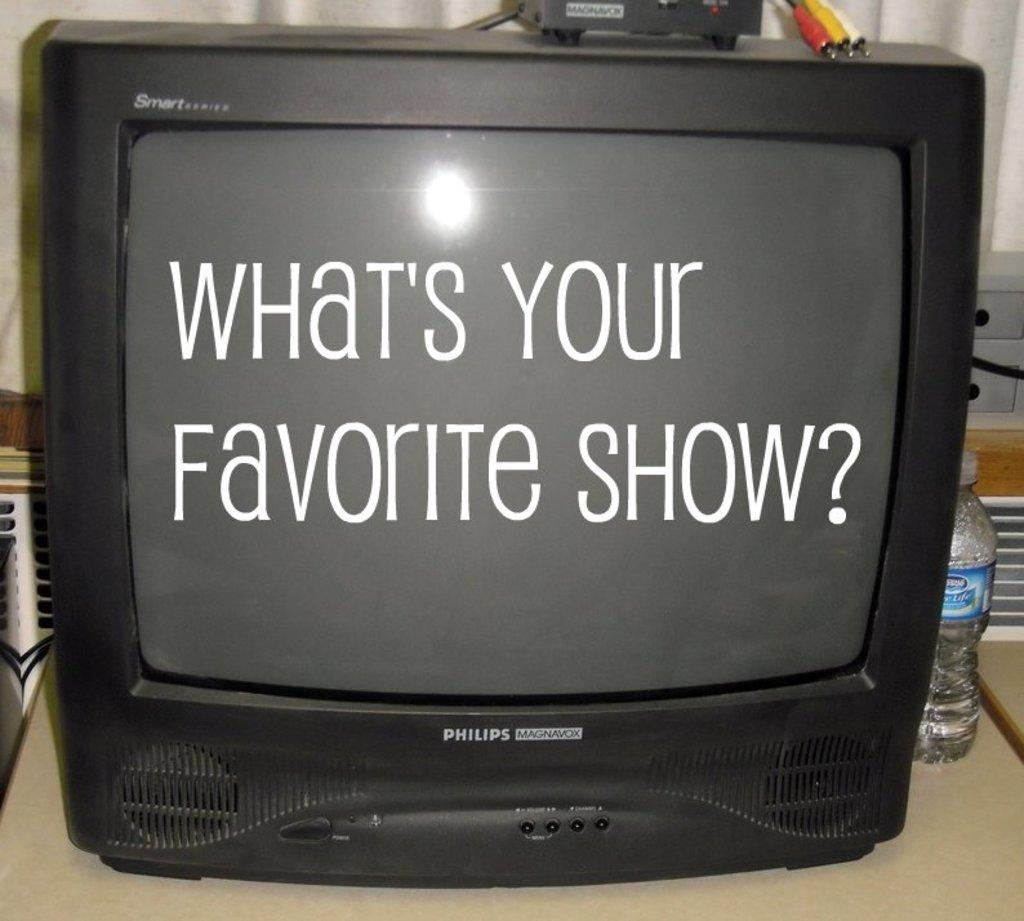<image>
Write a terse but informative summary of the picture. A Philips Magnavox Smartseries television that says What's your favorite show on it. 